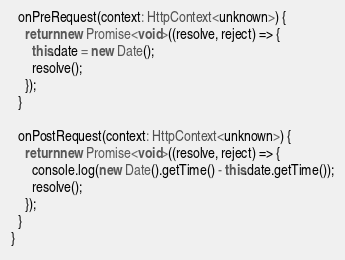<code> <loc_0><loc_0><loc_500><loc_500><_TypeScript_>
  onPreRequest(context: HttpContext<unknown>) {
    return new Promise<void>((resolve, reject) => {
      this.date = new Date();
      resolve();
    });
  }

  onPostRequest(context: HttpContext<unknown>) {
    return new Promise<void>((resolve, reject) => {
      console.log(new Date().getTime() - this.date.getTime());
      resolve();
    });
  }
}
</code> 